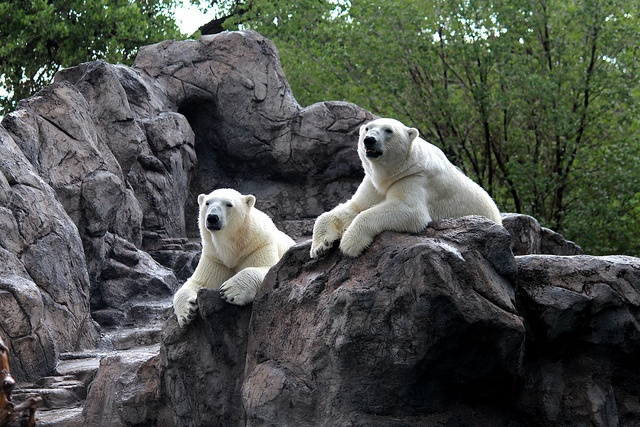Describe the objects in this image and their specific colors. I can see bear in black, gray, darkgray, and lightgray tones and bear in black, white, darkgray, and gray tones in this image. 